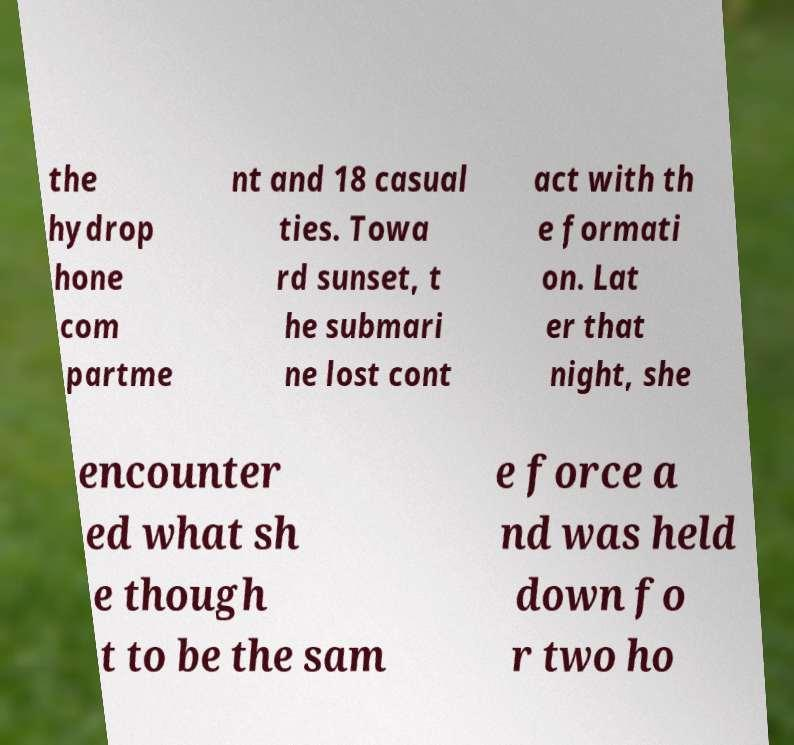There's text embedded in this image that I need extracted. Can you transcribe it verbatim? the hydrop hone com partme nt and 18 casual ties. Towa rd sunset, t he submari ne lost cont act with th e formati on. Lat er that night, she encounter ed what sh e though t to be the sam e force a nd was held down fo r two ho 